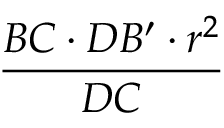<formula> <loc_0><loc_0><loc_500><loc_500>\frac { B C \cdot D B ^ { \prime } \cdot r ^ { 2 } } { D C }</formula> 